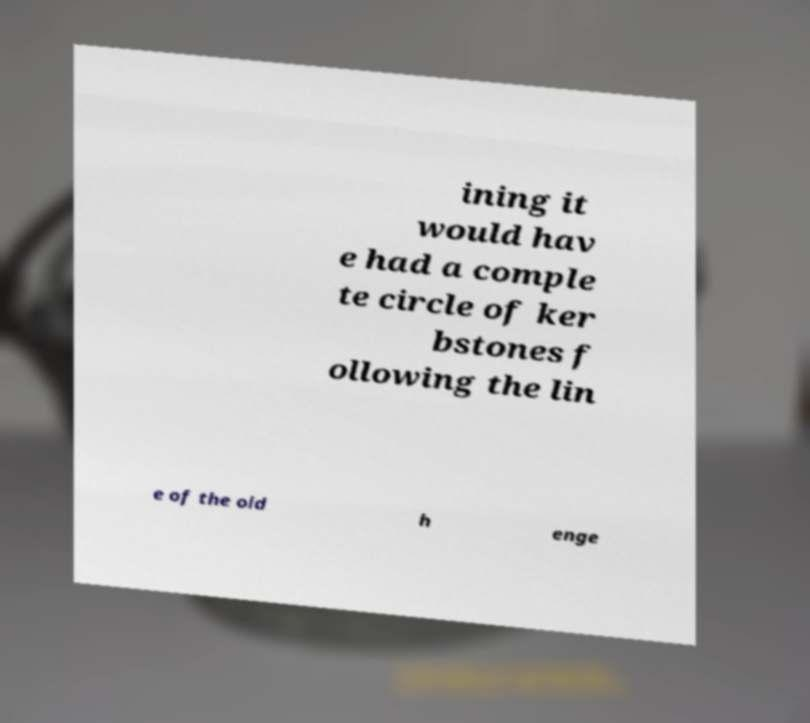Could you assist in decoding the text presented in this image and type it out clearly? ining it would hav e had a comple te circle of ker bstones f ollowing the lin e of the old h enge 